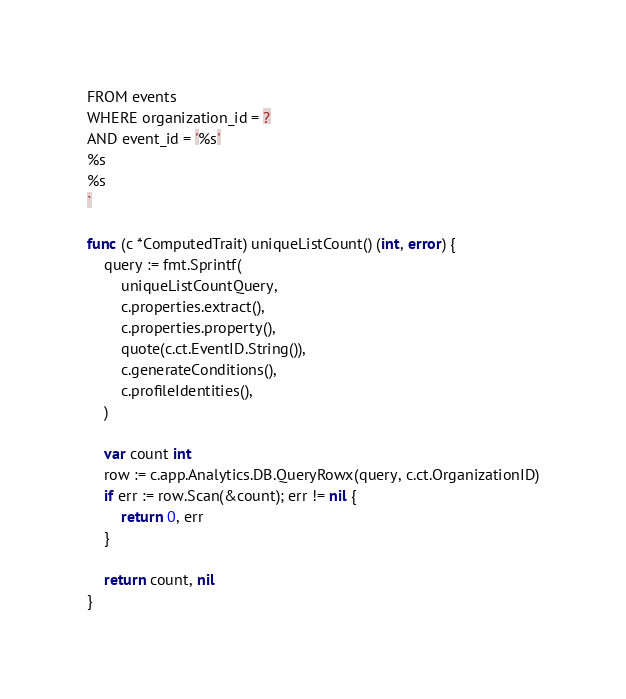<code> <loc_0><loc_0><loc_500><loc_500><_Go_>FROM events
WHERE organization_id = ?
AND event_id = '%s'
%s
%s
`

func (c *ComputedTrait) uniqueListCount() (int, error) {
	query := fmt.Sprintf(
		uniqueListCountQuery,
		c.properties.extract(),
		c.properties.property(),
		quote(c.ct.EventID.String()),
		c.generateConditions(),
		c.profileIdentities(),
	)

	var count int
	row := c.app.Analytics.DB.QueryRowx(query, c.ct.OrganizationID)
	if err := row.Scan(&count); err != nil {
		return 0, err
	}

	return count, nil
}
</code> 